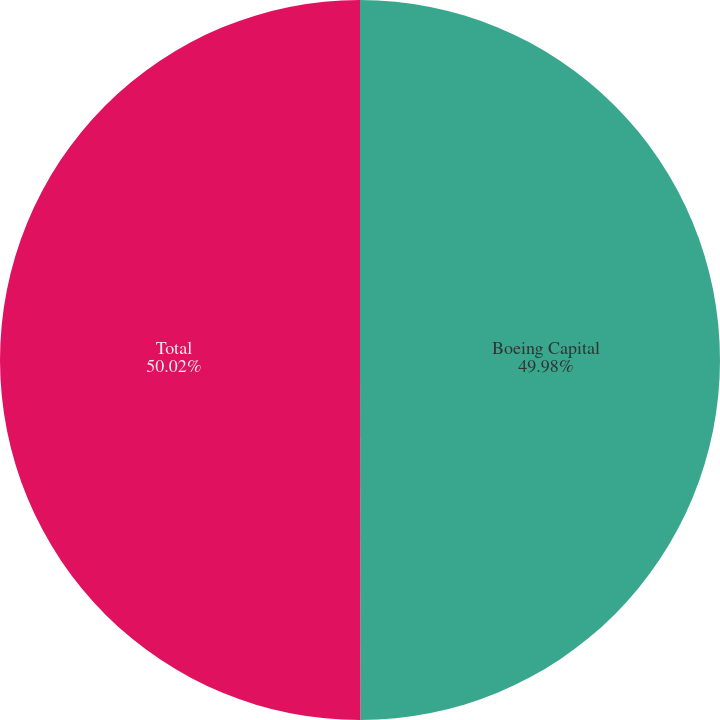Convert chart to OTSL. <chart><loc_0><loc_0><loc_500><loc_500><pie_chart><fcel>Boeing Capital<fcel>Total<nl><fcel>49.98%<fcel>50.02%<nl></chart> 